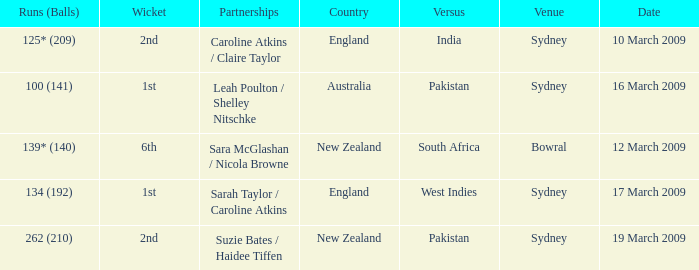How many times was the opponent country India?  1.0. 